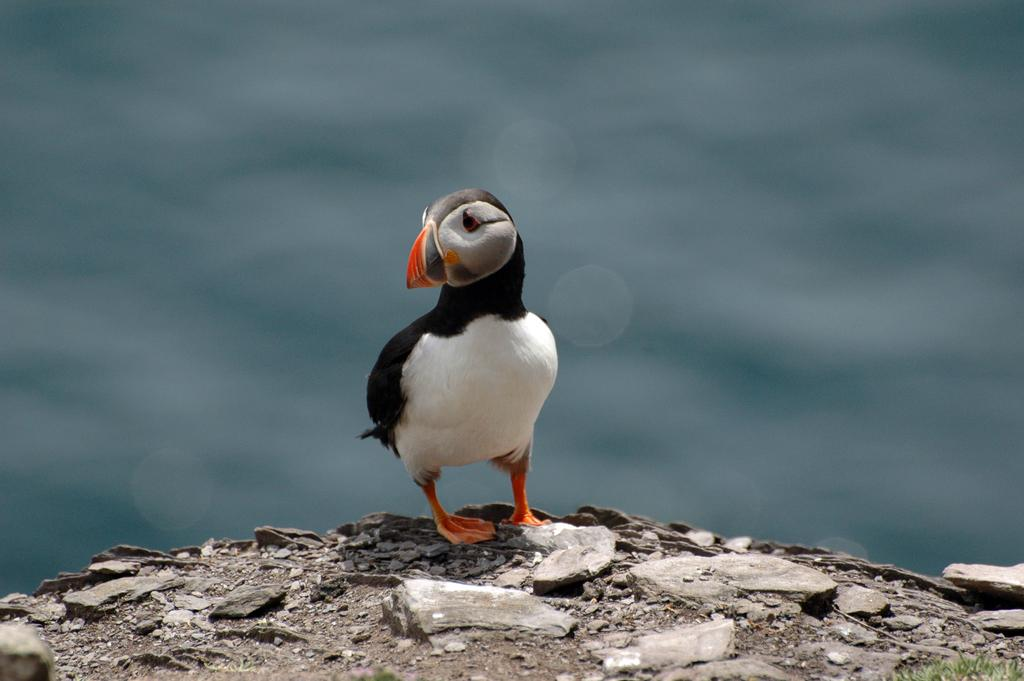What type of animal can be seen in the image? There is a bird in the image. Where is the bird located? The bird is on the ground. Can you describe the background of the image? The background of the image is slightly blurred. What time of day is it in the image, based on the bird's stomach? There is no information about the bird's stomach or the time of day in the image. 